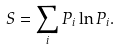<formula> <loc_0><loc_0><loc_500><loc_500>S = \sum _ { i } P _ { i } \ln P _ { i } .</formula> 